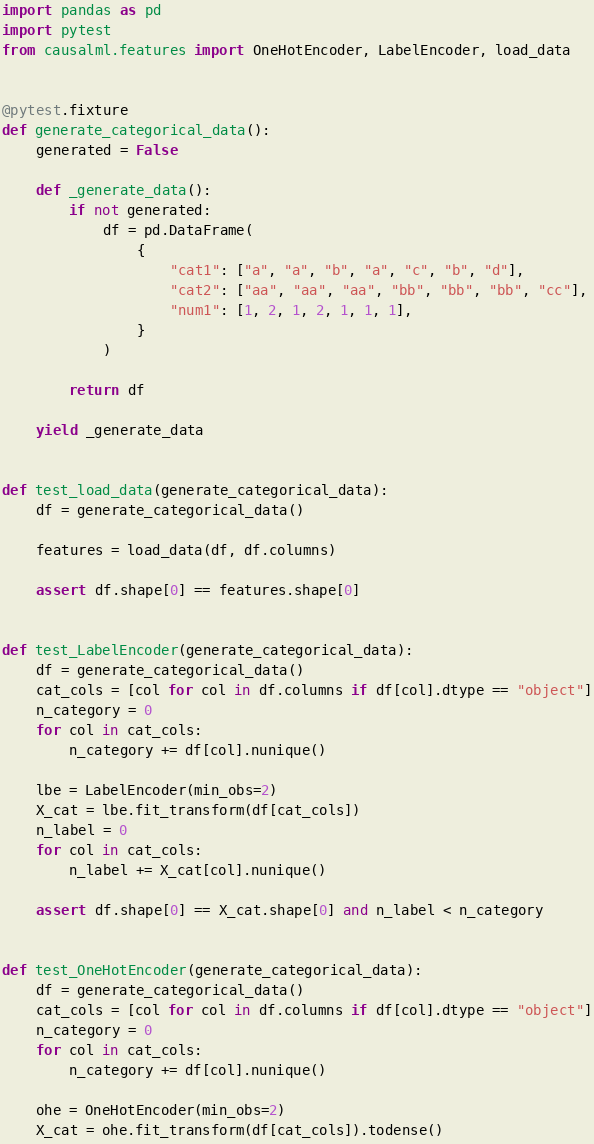<code> <loc_0><loc_0><loc_500><loc_500><_Python_>import pandas as pd
import pytest
from causalml.features import OneHotEncoder, LabelEncoder, load_data


@pytest.fixture
def generate_categorical_data():
    generated = False

    def _generate_data():
        if not generated:
            df = pd.DataFrame(
                {
                    "cat1": ["a", "a", "b", "a", "c", "b", "d"],
                    "cat2": ["aa", "aa", "aa", "bb", "bb", "bb", "cc"],
                    "num1": [1, 2, 1, 2, 1, 1, 1],
                }
            )

        return df

    yield _generate_data


def test_load_data(generate_categorical_data):
    df = generate_categorical_data()

    features = load_data(df, df.columns)

    assert df.shape[0] == features.shape[0]


def test_LabelEncoder(generate_categorical_data):
    df = generate_categorical_data()
    cat_cols = [col for col in df.columns if df[col].dtype == "object"]
    n_category = 0
    for col in cat_cols:
        n_category += df[col].nunique()

    lbe = LabelEncoder(min_obs=2)
    X_cat = lbe.fit_transform(df[cat_cols])
    n_label = 0
    for col in cat_cols:
        n_label += X_cat[col].nunique()

    assert df.shape[0] == X_cat.shape[0] and n_label < n_category


def test_OneHotEncoder(generate_categorical_data):
    df = generate_categorical_data()
    cat_cols = [col for col in df.columns if df[col].dtype == "object"]
    n_category = 0
    for col in cat_cols:
        n_category += df[col].nunique()

    ohe = OneHotEncoder(min_obs=2)
    X_cat = ohe.fit_transform(df[cat_cols]).todense()
</code> 